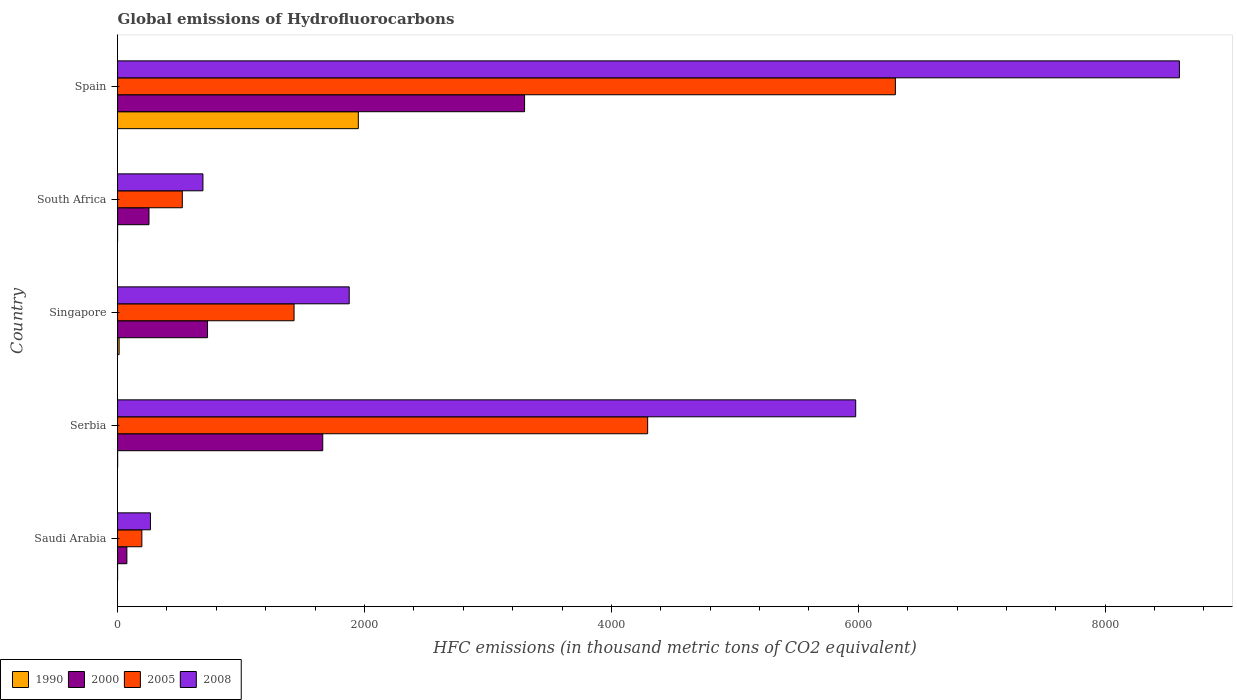Are the number of bars per tick equal to the number of legend labels?
Your response must be concise. Yes. How many bars are there on the 2nd tick from the top?
Ensure brevity in your answer.  4. In how many cases, is the number of bars for a given country not equal to the number of legend labels?
Make the answer very short. 0. What is the global emissions of Hydrofluorocarbons in 2008 in Serbia?
Your response must be concise. 5979. Across all countries, what is the maximum global emissions of Hydrofluorocarbons in 2008?
Make the answer very short. 8600.9. Across all countries, what is the minimum global emissions of Hydrofluorocarbons in 2008?
Your response must be concise. 266.5. In which country was the global emissions of Hydrofluorocarbons in 2005 maximum?
Offer a terse response. Spain. In which country was the global emissions of Hydrofluorocarbons in 2000 minimum?
Your answer should be very brief. Saudi Arabia. What is the total global emissions of Hydrofluorocarbons in 2000 in the graph?
Offer a very short reply. 6017.8. What is the difference between the global emissions of Hydrofluorocarbons in 2005 in Serbia and that in Singapore?
Offer a terse response. 2864.1. What is the difference between the global emissions of Hydrofluorocarbons in 2005 in Singapore and the global emissions of Hydrofluorocarbons in 2008 in Spain?
Make the answer very short. -7171.2. What is the average global emissions of Hydrofluorocarbons in 2005 per country?
Offer a terse response. 2549.04. What is the difference between the global emissions of Hydrofluorocarbons in 1990 and global emissions of Hydrofluorocarbons in 2000 in Serbia?
Your answer should be very brief. -1661.5. What is the ratio of the global emissions of Hydrofluorocarbons in 2000 in Serbia to that in South Africa?
Your response must be concise. 6.53. Is the global emissions of Hydrofluorocarbons in 2000 in Singapore less than that in Spain?
Your response must be concise. Yes. Is the difference between the global emissions of Hydrofluorocarbons in 1990 in Serbia and South Africa greater than the difference between the global emissions of Hydrofluorocarbons in 2000 in Serbia and South Africa?
Provide a succinct answer. No. What is the difference between the highest and the second highest global emissions of Hydrofluorocarbons in 2008?
Make the answer very short. 2621.9. What is the difference between the highest and the lowest global emissions of Hydrofluorocarbons in 2005?
Give a very brief answer. 6103.4. Is the sum of the global emissions of Hydrofluorocarbons in 2005 in Saudi Arabia and Singapore greater than the maximum global emissions of Hydrofluorocarbons in 2000 across all countries?
Your response must be concise. No. Is it the case that in every country, the sum of the global emissions of Hydrofluorocarbons in 2000 and global emissions of Hydrofluorocarbons in 1990 is greater than the sum of global emissions of Hydrofluorocarbons in 2008 and global emissions of Hydrofluorocarbons in 2005?
Provide a succinct answer. No. What does the 3rd bar from the top in Spain represents?
Your answer should be very brief. 2000. What does the 2nd bar from the bottom in South Africa represents?
Provide a short and direct response. 2000. How many bars are there?
Make the answer very short. 20. Are all the bars in the graph horizontal?
Offer a very short reply. Yes. What is the difference between two consecutive major ticks on the X-axis?
Offer a very short reply. 2000. Does the graph contain any zero values?
Your response must be concise. No. How many legend labels are there?
Ensure brevity in your answer.  4. How are the legend labels stacked?
Give a very brief answer. Horizontal. What is the title of the graph?
Your answer should be very brief. Global emissions of Hydrofluorocarbons. What is the label or title of the X-axis?
Provide a succinct answer. HFC emissions (in thousand metric tons of CO2 equivalent). What is the HFC emissions (in thousand metric tons of CO2 equivalent) in 1990 in Saudi Arabia?
Your response must be concise. 0.1. What is the HFC emissions (in thousand metric tons of CO2 equivalent) in 2000 in Saudi Arabia?
Your answer should be compact. 75.5. What is the HFC emissions (in thousand metric tons of CO2 equivalent) in 2005 in Saudi Arabia?
Keep it short and to the point. 196.9. What is the HFC emissions (in thousand metric tons of CO2 equivalent) of 2008 in Saudi Arabia?
Keep it short and to the point. 266.5. What is the HFC emissions (in thousand metric tons of CO2 equivalent) of 2000 in Serbia?
Ensure brevity in your answer.  1662. What is the HFC emissions (in thousand metric tons of CO2 equivalent) in 2005 in Serbia?
Give a very brief answer. 4293.8. What is the HFC emissions (in thousand metric tons of CO2 equivalent) in 2008 in Serbia?
Provide a short and direct response. 5979. What is the HFC emissions (in thousand metric tons of CO2 equivalent) in 1990 in Singapore?
Your response must be concise. 12.6. What is the HFC emissions (in thousand metric tons of CO2 equivalent) in 2000 in Singapore?
Keep it short and to the point. 728.9. What is the HFC emissions (in thousand metric tons of CO2 equivalent) of 2005 in Singapore?
Your answer should be compact. 1429.7. What is the HFC emissions (in thousand metric tons of CO2 equivalent) in 2008 in Singapore?
Ensure brevity in your answer.  1876.4. What is the HFC emissions (in thousand metric tons of CO2 equivalent) of 1990 in South Africa?
Offer a very short reply. 0.2. What is the HFC emissions (in thousand metric tons of CO2 equivalent) of 2000 in South Africa?
Keep it short and to the point. 254.6. What is the HFC emissions (in thousand metric tons of CO2 equivalent) in 2005 in South Africa?
Offer a very short reply. 524.5. What is the HFC emissions (in thousand metric tons of CO2 equivalent) in 2008 in South Africa?
Give a very brief answer. 691.6. What is the HFC emissions (in thousand metric tons of CO2 equivalent) of 1990 in Spain?
Provide a short and direct response. 1950.3. What is the HFC emissions (in thousand metric tons of CO2 equivalent) of 2000 in Spain?
Ensure brevity in your answer.  3296.8. What is the HFC emissions (in thousand metric tons of CO2 equivalent) of 2005 in Spain?
Your answer should be compact. 6300.3. What is the HFC emissions (in thousand metric tons of CO2 equivalent) of 2008 in Spain?
Make the answer very short. 8600.9. Across all countries, what is the maximum HFC emissions (in thousand metric tons of CO2 equivalent) of 1990?
Keep it short and to the point. 1950.3. Across all countries, what is the maximum HFC emissions (in thousand metric tons of CO2 equivalent) in 2000?
Your answer should be very brief. 3296.8. Across all countries, what is the maximum HFC emissions (in thousand metric tons of CO2 equivalent) in 2005?
Give a very brief answer. 6300.3. Across all countries, what is the maximum HFC emissions (in thousand metric tons of CO2 equivalent) of 2008?
Provide a short and direct response. 8600.9. Across all countries, what is the minimum HFC emissions (in thousand metric tons of CO2 equivalent) in 1990?
Offer a very short reply. 0.1. Across all countries, what is the minimum HFC emissions (in thousand metric tons of CO2 equivalent) of 2000?
Your answer should be very brief. 75.5. Across all countries, what is the minimum HFC emissions (in thousand metric tons of CO2 equivalent) in 2005?
Offer a very short reply. 196.9. Across all countries, what is the minimum HFC emissions (in thousand metric tons of CO2 equivalent) of 2008?
Provide a succinct answer. 266.5. What is the total HFC emissions (in thousand metric tons of CO2 equivalent) of 1990 in the graph?
Offer a terse response. 1963.7. What is the total HFC emissions (in thousand metric tons of CO2 equivalent) in 2000 in the graph?
Provide a succinct answer. 6017.8. What is the total HFC emissions (in thousand metric tons of CO2 equivalent) in 2005 in the graph?
Keep it short and to the point. 1.27e+04. What is the total HFC emissions (in thousand metric tons of CO2 equivalent) of 2008 in the graph?
Your response must be concise. 1.74e+04. What is the difference between the HFC emissions (in thousand metric tons of CO2 equivalent) in 1990 in Saudi Arabia and that in Serbia?
Make the answer very short. -0.4. What is the difference between the HFC emissions (in thousand metric tons of CO2 equivalent) of 2000 in Saudi Arabia and that in Serbia?
Ensure brevity in your answer.  -1586.5. What is the difference between the HFC emissions (in thousand metric tons of CO2 equivalent) in 2005 in Saudi Arabia and that in Serbia?
Provide a succinct answer. -4096.9. What is the difference between the HFC emissions (in thousand metric tons of CO2 equivalent) of 2008 in Saudi Arabia and that in Serbia?
Offer a very short reply. -5712.5. What is the difference between the HFC emissions (in thousand metric tons of CO2 equivalent) in 2000 in Saudi Arabia and that in Singapore?
Your response must be concise. -653.4. What is the difference between the HFC emissions (in thousand metric tons of CO2 equivalent) in 2005 in Saudi Arabia and that in Singapore?
Provide a short and direct response. -1232.8. What is the difference between the HFC emissions (in thousand metric tons of CO2 equivalent) of 2008 in Saudi Arabia and that in Singapore?
Provide a succinct answer. -1609.9. What is the difference between the HFC emissions (in thousand metric tons of CO2 equivalent) in 1990 in Saudi Arabia and that in South Africa?
Your answer should be very brief. -0.1. What is the difference between the HFC emissions (in thousand metric tons of CO2 equivalent) of 2000 in Saudi Arabia and that in South Africa?
Offer a very short reply. -179.1. What is the difference between the HFC emissions (in thousand metric tons of CO2 equivalent) in 2005 in Saudi Arabia and that in South Africa?
Make the answer very short. -327.6. What is the difference between the HFC emissions (in thousand metric tons of CO2 equivalent) in 2008 in Saudi Arabia and that in South Africa?
Offer a very short reply. -425.1. What is the difference between the HFC emissions (in thousand metric tons of CO2 equivalent) in 1990 in Saudi Arabia and that in Spain?
Provide a succinct answer. -1950.2. What is the difference between the HFC emissions (in thousand metric tons of CO2 equivalent) in 2000 in Saudi Arabia and that in Spain?
Keep it short and to the point. -3221.3. What is the difference between the HFC emissions (in thousand metric tons of CO2 equivalent) of 2005 in Saudi Arabia and that in Spain?
Provide a succinct answer. -6103.4. What is the difference between the HFC emissions (in thousand metric tons of CO2 equivalent) of 2008 in Saudi Arabia and that in Spain?
Offer a terse response. -8334.4. What is the difference between the HFC emissions (in thousand metric tons of CO2 equivalent) of 2000 in Serbia and that in Singapore?
Your response must be concise. 933.1. What is the difference between the HFC emissions (in thousand metric tons of CO2 equivalent) in 2005 in Serbia and that in Singapore?
Provide a short and direct response. 2864.1. What is the difference between the HFC emissions (in thousand metric tons of CO2 equivalent) of 2008 in Serbia and that in Singapore?
Ensure brevity in your answer.  4102.6. What is the difference between the HFC emissions (in thousand metric tons of CO2 equivalent) in 1990 in Serbia and that in South Africa?
Your answer should be compact. 0.3. What is the difference between the HFC emissions (in thousand metric tons of CO2 equivalent) in 2000 in Serbia and that in South Africa?
Your response must be concise. 1407.4. What is the difference between the HFC emissions (in thousand metric tons of CO2 equivalent) of 2005 in Serbia and that in South Africa?
Provide a succinct answer. 3769.3. What is the difference between the HFC emissions (in thousand metric tons of CO2 equivalent) of 2008 in Serbia and that in South Africa?
Ensure brevity in your answer.  5287.4. What is the difference between the HFC emissions (in thousand metric tons of CO2 equivalent) of 1990 in Serbia and that in Spain?
Keep it short and to the point. -1949.8. What is the difference between the HFC emissions (in thousand metric tons of CO2 equivalent) in 2000 in Serbia and that in Spain?
Provide a short and direct response. -1634.8. What is the difference between the HFC emissions (in thousand metric tons of CO2 equivalent) of 2005 in Serbia and that in Spain?
Offer a very short reply. -2006.5. What is the difference between the HFC emissions (in thousand metric tons of CO2 equivalent) in 2008 in Serbia and that in Spain?
Offer a terse response. -2621.9. What is the difference between the HFC emissions (in thousand metric tons of CO2 equivalent) of 1990 in Singapore and that in South Africa?
Ensure brevity in your answer.  12.4. What is the difference between the HFC emissions (in thousand metric tons of CO2 equivalent) in 2000 in Singapore and that in South Africa?
Your answer should be very brief. 474.3. What is the difference between the HFC emissions (in thousand metric tons of CO2 equivalent) in 2005 in Singapore and that in South Africa?
Provide a succinct answer. 905.2. What is the difference between the HFC emissions (in thousand metric tons of CO2 equivalent) in 2008 in Singapore and that in South Africa?
Offer a terse response. 1184.8. What is the difference between the HFC emissions (in thousand metric tons of CO2 equivalent) of 1990 in Singapore and that in Spain?
Your response must be concise. -1937.7. What is the difference between the HFC emissions (in thousand metric tons of CO2 equivalent) in 2000 in Singapore and that in Spain?
Ensure brevity in your answer.  -2567.9. What is the difference between the HFC emissions (in thousand metric tons of CO2 equivalent) of 2005 in Singapore and that in Spain?
Provide a succinct answer. -4870.6. What is the difference between the HFC emissions (in thousand metric tons of CO2 equivalent) in 2008 in Singapore and that in Spain?
Keep it short and to the point. -6724.5. What is the difference between the HFC emissions (in thousand metric tons of CO2 equivalent) of 1990 in South Africa and that in Spain?
Give a very brief answer. -1950.1. What is the difference between the HFC emissions (in thousand metric tons of CO2 equivalent) of 2000 in South Africa and that in Spain?
Provide a succinct answer. -3042.2. What is the difference between the HFC emissions (in thousand metric tons of CO2 equivalent) in 2005 in South Africa and that in Spain?
Your answer should be very brief. -5775.8. What is the difference between the HFC emissions (in thousand metric tons of CO2 equivalent) in 2008 in South Africa and that in Spain?
Your response must be concise. -7909.3. What is the difference between the HFC emissions (in thousand metric tons of CO2 equivalent) in 1990 in Saudi Arabia and the HFC emissions (in thousand metric tons of CO2 equivalent) in 2000 in Serbia?
Keep it short and to the point. -1661.9. What is the difference between the HFC emissions (in thousand metric tons of CO2 equivalent) of 1990 in Saudi Arabia and the HFC emissions (in thousand metric tons of CO2 equivalent) of 2005 in Serbia?
Offer a very short reply. -4293.7. What is the difference between the HFC emissions (in thousand metric tons of CO2 equivalent) of 1990 in Saudi Arabia and the HFC emissions (in thousand metric tons of CO2 equivalent) of 2008 in Serbia?
Offer a very short reply. -5978.9. What is the difference between the HFC emissions (in thousand metric tons of CO2 equivalent) in 2000 in Saudi Arabia and the HFC emissions (in thousand metric tons of CO2 equivalent) in 2005 in Serbia?
Make the answer very short. -4218.3. What is the difference between the HFC emissions (in thousand metric tons of CO2 equivalent) of 2000 in Saudi Arabia and the HFC emissions (in thousand metric tons of CO2 equivalent) of 2008 in Serbia?
Give a very brief answer. -5903.5. What is the difference between the HFC emissions (in thousand metric tons of CO2 equivalent) of 2005 in Saudi Arabia and the HFC emissions (in thousand metric tons of CO2 equivalent) of 2008 in Serbia?
Ensure brevity in your answer.  -5782.1. What is the difference between the HFC emissions (in thousand metric tons of CO2 equivalent) of 1990 in Saudi Arabia and the HFC emissions (in thousand metric tons of CO2 equivalent) of 2000 in Singapore?
Your answer should be compact. -728.8. What is the difference between the HFC emissions (in thousand metric tons of CO2 equivalent) in 1990 in Saudi Arabia and the HFC emissions (in thousand metric tons of CO2 equivalent) in 2005 in Singapore?
Ensure brevity in your answer.  -1429.6. What is the difference between the HFC emissions (in thousand metric tons of CO2 equivalent) of 1990 in Saudi Arabia and the HFC emissions (in thousand metric tons of CO2 equivalent) of 2008 in Singapore?
Keep it short and to the point. -1876.3. What is the difference between the HFC emissions (in thousand metric tons of CO2 equivalent) of 2000 in Saudi Arabia and the HFC emissions (in thousand metric tons of CO2 equivalent) of 2005 in Singapore?
Ensure brevity in your answer.  -1354.2. What is the difference between the HFC emissions (in thousand metric tons of CO2 equivalent) in 2000 in Saudi Arabia and the HFC emissions (in thousand metric tons of CO2 equivalent) in 2008 in Singapore?
Make the answer very short. -1800.9. What is the difference between the HFC emissions (in thousand metric tons of CO2 equivalent) of 2005 in Saudi Arabia and the HFC emissions (in thousand metric tons of CO2 equivalent) of 2008 in Singapore?
Your answer should be compact. -1679.5. What is the difference between the HFC emissions (in thousand metric tons of CO2 equivalent) of 1990 in Saudi Arabia and the HFC emissions (in thousand metric tons of CO2 equivalent) of 2000 in South Africa?
Ensure brevity in your answer.  -254.5. What is the difference between the HFC emissions (in thousand metric tons of CO2 equivalent) of 1990 in Saudi Arabia and the HFC emissions (in thousand metric tons of CO2 equivalent) of 2005 in South Africa?
Offer a terse response. -524.4. What is the difference between the HFC emissions (in thousand metric tons of CO2 equivalent) of 1990 in Saudi Arabia and the HFC emissions (in thousand metric tons of CO2 equivalent) of 2008 in South Africa?
Keep it short and to the point. -691.5. What is the difference between the HFC emissions (in thousand metric tons of CO2 equivalent) in 2000 in Saudi Arabia and the HFC emissions (in thousand metric tons of CO2 equivalent) in 2005 in South Africa?
Keep it short and to the point. -449. What is the difference between the HFC emissions (in thousand metric tons of CO2 equivalent) of 2000 in Saudi Arabia and the HFC emissions (in thousand metric tons of CO2 equivalent) of 2008 in South Africa?
Your answer should be very brief. -616.1. What is the difference between the HFC emissions (in thousand metric tons of CO2 equivalent) in 2005 in Saudi Arabia and the HFC emissions (in thousand metric tons of CO2 equivalent) in 2008 in South Africa?
Your response must be concise. -494.7. What is the difference between the HFC emissions (in thousand metric tons of CO2 equivalent) of 1990 in Saudi Arabia and the HFC emissions (in thousand metric tons of CO2 equivalent) of 2000 in Spain?
Your answer should be very brief. -3296.7. What is the difference between the HFC emissions (in thousand metric tons of CO2 equivalent) of 1990 in Saudi Arabia and the HFC emissions (in thousand metric tons of CO2 equivalent) of 2005 in Spain?
Your response must be concise. -6300.2. What is the difference between the HFC emissions (in thousand metric tons of CO2 equivalent) in 1990 in Saudi Arabia and the HFC emissions (in thousand metric tons of CO2 equivalent) in 2008 in Spain?
Your response must be concise. -8600.8. What is the difference between the HFC emissions (in thousand metric tons of CO2 equivalent) in 2000 in Saudi Arabia and the HFC emissions (in thousand metric tons of CO2 equivalent) in 2005 in Spain?
Provide a short and direct response. -6224.8. What is the difference between the HFC emissions (in thousand metric tons of CO2 equivalent) of 2000 in Saudi Arabia and the HFC emissions (in thousand metric tons of CO2 equivalent) of 2008 in Spain?
Give a very brief answer. -8525.4. What is the difference between the HFC emissions (in thousand metric tons of CO2 equivalent) of 2005 in Saudi Arabia and the HFC emissions (in thousand metric tons of CO2 equivalent) of 2008 in Spain?
Your response must be concise. -8404. What is the difference between the HFC emissions (in thousand metric tons of CO2 equivalent) of 1990 in Serbia and the HFC emissions (in thousand metric tons of CO2 equivalent) of 2000 in Singapore?
Give a very brief answer. -728.4. What is the difference between the HFC emissions (in thousand metric tons of CO2 equivalent) of 1990 in Serbia and the HFC emissions (in thousand metric tons of CO2 equivalent) of 2005 in Singapore?
Your answer should be very brief. -1429.2. What is the difference between the HFC emissions (in thousand metric tons of CO2 equivalent) in 1990 in Serbia and the HFC emissions (in thousand metric tons of CO2 equivalent) in 2008 in Singapore?
Offer a very short reply. -1875.9. What is the difference between the HFC emissions (in thousand metric tons of CO2 equivalent) in 2000 in Serbia and the HFC emissions (in thousand metric tons of CO2 equivalent) in 2005 in Singapore?
Keep it short and to the point. 232.3. What is the difference between the HFC emissions (in thousand metric tons of CO2 equivalent) in 2000 in Serbia and the HFC emissions (in thousand metric tons of CO2 equivalent) in 2008 in Singapore?
Ensure brevity in your answer.  -214.4. What is the difference between the HFC emissions (in thousand metric tons of CO2 equivalent) in 2005 in Serbia and the HFC emissions (in thousand metric tons of CO2 equivalent) in 2008 in Singapore?
Your answer should be very brief. 2417.4. What is the difference between the HFC emissions (in thousand metric tons of CO2 equivalent) in 1990 in Serbia and the HFC emissions (in thousand metric tons of CO2 equivalent) in 2000 in South Africa?
Give a very brief answer. -254.1. What is the difference between the HFC emissions (in thousand metric tons of CO2 equivalent) of 1990 in Serbia and the HFC emissions (in thousand metric tons of CO2 equivalent) of 2005 in South Africa?
Keep it short and to the point. -524. What is the difference between the HFC emissions (in thousand metric tons of CO2 equivalent) in 1990 in Serbia and the HFC emissions (in thousand metric tons of CO2 equivalent) in 2008 in South Africa?
Offer a terse response. -691.1. What is the difference between the HFC emissions (in thousand metric tons of CO2 equivalent) in 2000 in Serbia and the HFC emissions (in thousand metric tons of CO2 equivalent) in 2005 in South Africa?
Your answer should be compact. 1137.5. What is the difference between the HFC emissions (in thousand metric tons of CO2 equivalent) of 2000 in Serbia and the HFC emissions (in thousand metric tons of CO2 equivalent) of 2008 in South Africa?
Keep it short and to the point. 970.4. What is the difference between the HFC emissions (in thousand metric tons of CO2 equivalent) in 2005 in Serbia and the HFC emissions (in thousand metric tons of CO2 equivalent) in 2008 in South Africa?
Provide a short and direct response. 3602.2. What is the difference between the HFC emissions (in thousand metric tons of CO2 equivalent) in 1990 in Serbia and the HFC emissions (in thousand metric tons of CO2 equivalent) in 2000 in Spain?
Offer a terse response. -3296.3. What is the difference between the HFC emissions (in thousand metric tons of CO2 equivalent) of 1990 in Serbia and the HFC emissions (in thousand metric tons of CO2 equivalent) of 2005 in Spain?
Your answer should be compact. -6299.8. What is the difference between the HFC emissions (in thousand metric tons of CO2 equivalent) of 1990 in Serbia and the HFC emissions (in thousand metric tons of CO2 equivalent) of 2008 in Spain?
Give a very brief answer. -8600.4. What is the difference between the HFC emissions (in thousand metric tons of CO2 equivalent) of 2000 in Serbia and the HFC emissions (in thousand metric tons of CO2 equivalent) of 2005 in Spain?
Your answer should be compact. -4638.3. What is the difference between the HFC emissions (in thousand metric tons of CO2 equivalent) in 2000 in Serbia and the HFC emissions (in thousand metric tons of CO2 equivalent) in 2008 in Spain?
Keep it short and to the point. -6938.9. What is the difference between the HFC emissions (in thousand metric tons of CO2 equivalent) in 2005 in Serbia and the HFC emissions (in thousand metric tons of CO2 equivalent) in 2008 in Spain?
Give a very brief answer. -4307.1. What is the difference between the HFC emissions (in thousand metric tons of CO2 equivalent) in 1990 in Singapore and the HFC emissions (in thousand metric tons of CO2 equivalent) in 2000 in South Africa?
Your response must be concise. -242. What is the difference between the HFC emissions (in thousand metric tons of CO2 equivalent) of 1990 in Singapore and the HFC emissions (in thousand metric tons of CO2 equivalent) of 2005 in South Africa?
Keep it short and to the point. -511.9. What is the difference between the HFC emissions (in thousand metric tons of CO2 equivalent) in 1990 in Singapore and the HFC emissions (in thousand metric tons of CO2 equivalent) in 2008 in South Africa?
Your answer should be compact. -679. What is the difference between the HFC emissions (in thousand metric tons of CO2 equivalent) in 2000 in Singapore and the HFC emissions (in thousand metric tons of CO2 equivalent) in 2005 in South Africa?
Offer a very short reply. 204.4. What is the difference between the HFC emissions (in thousand metric tons of CO2 equivalent) in 2000 in Singapore and the HFC emissions (in thousand metric tons of CO2 equivalent) in 2008 in South Africa?
Keep it short and to the point. 37.3. What is the difference between the HFC emissions (in thousand metric tons of CO2 equivalent) in 2005 in Singapore and the HFC emissions (in thousand metric tons of CO2 equivalent) in 2008 in South Africa?
Offer a very short reply. 738.1. What is the difference between the HFC emissions (in thousand metric tons of CO2 equivalent) of 1990 in Singapore and the HFC emissions (in thousand metric tons of CO2 equivalent) of 2000 in Spain?
Your answer should be very brief. -3284.2. What is the difference between the HFC emissions (in thousand metric tons of CO2 equivalent) of 1990 in Singapore and the HFC emissions (in thousand metric tons of CO2 equivalent) of 2005 in Spain?
Your response must be concise. -6287.7. What is the difference between the HFC emissions (in thousand metric tons of CO2 equivalent) in 1990 in Singapore and the HFC emissions (in thousand metric tons of CO2 equivalent) in 2008 in Spain?
Make the answer very short. -8588.3. What is the difference between the HFC emissions (in thousand metric tons of CO2 equivalent) in 2000 in Singapore and the HFC emissions (in thousand metric tons of CO2 equivalent) in 2005 in Spain?
Offer a very short reply. -5571.4. What is the difference between the HFC emissions (in thousand metric tons of CO2 equivalent) of 2000 in Singapore and the HFC emissions (in thousand metric tons of CO2 equivalent) of 2008 in Spain?
Offer a very short reply. -7872. What is the difference between the HFC emissions (in thousand metric tons of CO2 equivalent) of 2005 in Singapore and the HFC emissions (in thousand metric tons of CO2 equivalent) of 2008 in Spain?
Keep it short and to the point. -7171.2. What is the difference between the HFC emissions (in thousand metric tons of CO2 equivalent) in 1990 in South Africa and the HFC emissions (in thousand metric tons of CO2 equivalent) in 2000 in Spain?
Your answer should be compact. -3296.6. What is the difference between the HFC emissions (in thousand metric tons of CO2 equivalent) in 1990 in South Africa and the HFC emissions (in thousand metric tons of CO2 equivalent) in 2005 in Spain?
Make the answer very short. -6300.1. What is the difference between the HFC emissions (in thousand metric tons of CO2 equivalent) of 1990 in South Africa and the HFC emissions (in thousand metric tons of CO2 equivalent) of 2008 in Spain?
Keep it short and to the point. -8600.7. What is the difference between the HFC emissions (in thousand metric tons of CO2 equivalent) in 2000 in South Africa and the HFC emissions (in thousand metric tons of CO2 equivalent) in 2005 in Spain?
Give a very brief answer. -6045.7. What is the difference between the HFC emissions (in thousand metric tons of CO2 equivalent) in 2000 in South Africa and the HFC emissions (in thousand metric tons of CO2 equivalent) in 2008 in Spain?
Provide a succinct answer. -8346.3. What is the difference between the HFC emissions (in thousand metric tons of CO2 equivalent) in 2005 in South Africa and the HFC emissions (in thousand metric tons of CO2 equivalent) in 2008 in Spain?
Keep it short and to the point. -8076.4. What is the average HFC emissions (in thousand metric tons of CO2 equivalent) in 1990 per country?
Provide a short and direct response. 392.74. What is the average HFC emissions (in thousand metric tons of CO2 equivalent) in 2000 per country?
Give a very brief answer. 1203.56. What is the average HFC emissions (in thousand metric tons of CO2 equivalent) in 2005 per country?
Your answer should be compact. 2549.04. What is the average HFC emissions (in thousand metric tons of CO2 equivalent) of 2008 per country?
Your response must be concise. 3482.88. What is the difference between the HFC emissions (in thousand metric tons of CO2 equivalent) of 1990 and HFC emissions (in thousand metric tons of CO2 equivalent) of 2000 in Saudi Arabia?
Provide a short and direct response. -75.4. What is the difference between the HFC emissions (in thousand metric tons of CO2 equivalent) of 1990 and HFC emissions (in thousand metric tons of CO2 equivalent) of 2005 in Saudi Arabia?
Ensure brevity in your answer.  -196.8. What is the difference between the HFC emissions (in thousand metric tons of CO2 equivalent) of 1990 and HFC emissions (in thousand metric tons of CO2 equivalent) of 2008 in Saudi Arabia?
Your response must be concise. -266.4. What is the difference between the HFC emissions (in thousand metric tons of CO2 equivalent) of 2000 and HFC emissions (in thousand metric tons of CO2 equivalent) of 2005 in Saudi Arabia?
Offer a very short reply. -121.4. What is the difference between the HFC emissions (in thousand metric tons of CO2 equivalent) of 2000 and HFC emissions (in thousand metric tons of CO2 equivalent) of 2008 in Saudi Arabia?
Offer a very short reply. -191. What is the difference between the HFC emissions (in thousand metric tons of CO2 equivalent) in 2005 and HFC emissions (in thousand metric tons of CO2 equivalent) in 2008 in Saudi Arabia?
Offer a very short reply. -69.6. What is the difference between the HFC emissions (in thousand metric tons of CO2 equivalent) in 1990 and HFC emissions (in thousand metric tons of CO2 equivalent) in 2000 in Serbia?
Keep it short and to the point. -1661.5. What is the difference between the HFC emissions (in thousand metric tons of CO2 equivalent) in 1990 and HFC emissions (in thousand metric tons of CO2 equivalent) in 2005 in Serbia?
Provide a succinct answer. -4293.3. What is the difference between the HFC emissions (in thousand metric tons of CO2 equivalent) in 1990 and HFC emissions (in thousand metric tons of CO2 equivalent) in 2008 in Serbia?
Your answer should be compact. -5978.5. What is the difference between the HFC emissions (in thousand metric tons of CO2 equivalent) in 2000 and HFC emissions (in thousand metric tons of CO2 equivalent) in 2005 in Serbia?
Provide a short and direct response. -2631.8. What is the difference between the HFC emissions (in thousand metric tons of CO2 equivalent) of 2000 and HFC emissions (in thousand metric tons of CO2 equivalent) of 2008 in Serbia?
Keep it short and to the point. -4317. What is the difference between the HFC emissions (in thousand metric tons of CO2 equivalent) of 2005 and HFC emissions (in thousand metric tons of CO2 equivalent) of 2008 in Serbia?
Provide a succinct answer. -1685.2. What is the difference between the HFC emissions (in thousand metric tons of CO2 equivalent) of 1990 and HFC emissions (in thousand metric tons of CO2 equivalent) of 2000 in Singapore?
Your response must be concise. -716.3. What is the difference between the HFC emissions (in thousand metric tons of CO2 equivalent) of 1990 and HFC emissions (in thousand metric tons of CO2 equivalent) of 2005 in Singapore?
Your response must be concise. -1417.1. What is the difference between the HFC emissions (in thousand metric tons of CO2 equivalent) in 1990 and HFC emissions (in thousand metric tons of CO2 equivalent) in 2008 in Singapore?
Your answer should be very brief. -1863.8. What is the difference between the HFC emissions (in thousand metric tons of CO2 equivalent) of 2000 and HFC emissions (in thousand metric tons of CO2 equivalent) of 2005 in Singapore?
Your answer should be very brief. -700.8. What is the difference between the HFC emissions (in thousand metric tons of CO2 equivalent) in 2000 and HFC emissions (in thousand metric tons of CO2 equivalent) in 2008 in Singapore?
Your answer should be compact. -1147.5. What is the difference between the HFC emissions (in thousand metric tons of CO2 equivalent) of 2005 and HFC emissions (in thousand metric tons of CO2 equivalent) of 2008 in Singapore?
Offer a terse response. -446.7. What is the difference between the HFC emissions (in thousand metric tons of CO2 equivalent) in 1990 and HFC emissions (in thousand metric tons of CO2 equivalent) in 2000 in South Africa?
Provide a short and direct response. -254.4. What is the difference between the HFC emissions (in thousand metric tons of CO2 equivalent) of 1990 and HFC emissions (in thousand metric tons of CO2 equivalent) of 2005 in South Africa?
Provide a succinct answer. -524.3. What is the difference between the HFC emissions (in thousand metric tons of CO2 equivalent) of 1990 and HFC emissions (in thousand metric tons of CO2 equivalent) of 2008 in South Africa?
Your answer should be compact. -691.4. What is the difference between the HFC emissions (in thousand metric tons of CO2 equivalent) in 2000 and HFC emissions (in thousand metric tons of CO2 equivalent) in 2005 in South Africa?
Your response must be concise. -269.9. What is the difference between the HFC emissions (in thousand metric tons of CO2 equivalent) of 2000 and HFC emissions (in thousand metric tons of CO2 equivalent) of 2008 in South Africa?
Make the answer very short. -437. What is the difference between the HFC emissions (in thousand metric tons of CO2 equivalent) in 2005 and HFC emissions (in thousand metric tons of CO2 equivalent) in 2008 in South Africa?
Give a very brief answer. -167.1. What is the difference between the HFC emissions (in thousand metric tons of CO2 equivalent) in 1990 and HFC emissions (in thousand metric tons of CO2 equivalent) in 2000 in Spain?
Your response must be concise. -1346.5. What is the difference between the HFC emissions (in thousand metric tons of CO2 equivalent) of 1990 and HFC emissions (in thousand metric tons of CO2 equivalent) of 2005 in Spain?
Offer a terse response. -4350. What is the difference between the HFC emissions (in thousand metric tons of CO2 equivalent) of 1990 and HFC emissions (in thousand metric tons of CO2 equivalent) of 2008 in Spain?
Your answer should be very brief. -6650.6. What is the difference between the HFC emissions (in thousand metric tons of CO2 equivalent) of 2000 and HFC emissions (in thousand metric tons of CO2 equivalent) of 2005 in Spain?
Ensure brevity in your answer.  -3003.5. What is the difference between the HFC emissions (in thousand metric tons of CO2 equivalent) in 2000 and HFC emissions (in thousand metric tons of CO2 equivalent) in 2008 in Spain?
Make the answer very short. -5304.1. What is the difference between the HFC emissions (in thousand metric tons of CO2 equivalent) of 2005 and HFC emissions (in thousand metric tons of CO2 equivalent) of 2008 in Spain?
Give a very brief answer. -2300.6. What is the ratio of the HFC emissions (in thousand metric tons of CO2 equivalent) of 2000 in Saudi Arabia to that in Serbia?
Your answer should be very brief. 0.05. What is the ratio of the HFC emissions (in thousand metric tons of CO2 equivalent) in 2005 in Saudi Arabia to that in Serbia?
Ensure brevity in your answer.  0.05. What is the ratio of the HFC emissions (in thousand metric tons of CO2 equivalent) in 2008 in Saudi Arabia to that in Serbia?
Give a very brief answer. 0.04. What is the ratio of the HFC emissions (in thousand metric tons of CO2 equivalent) in 1990 in Saudi Arabia to that in Singapore?
Give a very brief answer. 0.01. What is the ratio of the HFC emissions (in thousand metric tons of CO2 equivalent) in 2000 in Saudi Arabia to that in Singapore?
Give a very brief answer. 0.1. What is the ratio of the HFC emissions (in thousand metric tons of CO2 equivalent) of 2005 in Saudi Arabia to that in Singapore?
Offer a very short reply. 0.14. What is the ratio of the HFC emissions (in thousand metric tons of CO2 equivalent) in 2008 in Saudi Arabia to that in Singapore?
Give a very brief answer. 0.14. What is the ratio of the HFC emissions (in thousand metric tons of CO2 equivalent) of 2000 in Saudi Arabia to that in South Africa?
Give a very brief answer. 0.3. What is the ratio of the HFC emissions (in thousand metric tons of CO2 equivalent) of 2005 in Saudi Arabia to that in South Africa?
Offer a terse response. 0.38. What is the ratio of the HFC emissions (in thousand metric tons of CO2 equivalent) of 2008 in Saudi Arabia to that in South Africa?
Provide a succinct answer. 0.39. What is the ratio of the HFC emissions (in thousand metric tons of CO2 equivalent) in 2000 in Saudi Arabia to that in Spain?
Offer a very short reply. 0.02. What is the ratio of the HFC emissions (in thousand metric tons of CO2 equivalent) of 2005 in Saudi Arabia to that in Spain?
Provide a succinct answer. 0.03. What is the ratio of the HFC emissions (in thousand metric tons of CO2 equivalent) of 2008 in Saudi Arabia to that in Spain?
Offer a terse response. 0.03. What is the ratio of the HFC emissions (in thousand metric tons of CO2 equivalent) in 1990 in Serbia to that in Singapore?
Provide a succinct answer. 0.04. What is the ratio of the HFC emissions (in thousand metric tons of CO2 equivalent) in 2000 in Serbia to that in Singapore?
Provide a short and direct response. 2.28. What is the ratio of the HFC emissions (in thousand metric tons of CO2 equivalent) in 2005 in Serbia to that in Singapore?
Your answer should be very brief. 3. What is the ratio of the HFC emissions (in thousand metric tons of CO2 equivalent) of 2008 in Serbia to that in Singapore?
Give a very brief answer. 3.19. What is the ratio of the HFC emissions (in thousand metric tons of CO2 equivalent) of 2000 in Serbia to that in South Africa?
Offer a very short reply. 6.53. What is the ratio of the HFC emissions (in thousand metric tons of CO2 equivalent) in 2005 in Serbia to that in South Africa?
Keep it short and to the point. 8.19. What is the ratio of the HFC emissions (in thousand metric tons of CO2 equivalent) in 2008 in Serbia to that in South Africa?
Provide a short and direct response. 8.65. What is the ratio of the HFC emissions (in thousand metric tons of CO2 equivalent) in 1990 in Serbia to that in Spain?
Your answer should be compact. 0. What is the ratio of the HFC emissions (in thousand metric tons of CO2 equivalent) of 2000 in Serbia to that in Spain?
Give a very brief answer. 0.5. What is the ratio of the HFC emissions (in thousand metric tons of CO2 equivalent) of 2005 in Serbia to that in Spain?
Make the answer very short. 0.68. What is the ratio of the HFC emissions (in thousand metric tons of CO2 equivalent) in 2008 in Serbia to that in Spain?
Provide a short and direct response. 0.7. What is the ratio of the HFC emissions (in thousand metric tons of CO2 equivalent) of 2000 in Singapore to that in South Africa?
Your answer should be compact. 2.86. What is the ratio of the HFC emissions (in thousand metric tons of CO2 equivalent) of 2005 in Singapore to that in South Africa?
Keep it short and to the point. 2.73. What is the ratio of the HFC emissions (in thousand metric tons of CO2 equivalent) in 2008 in Singapore to that in South Africa?
Ensure brevity in your answer.  2.71. What is the ratio of the HFC emissions (in thousand metric tons of CO2 equivalent) of 1990 in Singapore to that in Spain?
Provide a succinct answer. 0.01. What is the ratio of the HFC emissions (in thousand metric tons of CO2 equivalent) in 2000 in Singapore to that in Spain?
Provide a succinct answer. 0.22. What is the ratio of the HFC emissions (in thousand metric tons of CO2 equivalent) of 2005 in Singapore to that in Spain?
Keep it short and to the point. 0.23. What is the ratio of the HFC emissions (in thousand metric tons of CO2 equivalent) in 2008 in Singapore to that in Spain?
Ensure brevity in your answer.  0.22. What is the ratio of the HFC emissions (in thousand metric tons of CO2 equivalent) of 2000 in South Africa to that in Spain?
Keep it short and to the point. 0.08. What is the ratio of the HFC emissions (in thousand metric tons of CO2 equivalent) in 2005 in South Africa to that in Spain?
Keep it short and to the point. 0.08. What is the ratio of the HFC emissions (in thousand metric tons of CO2 equivalent) in 2008 in South Africa to that in Spain?
Give a very brief answer. 0.08. What is the difference between the highest and the second highest HFC emissions (in thousand metric tons of CO2 equivalent) of 1990?
Ensure brevity in your answer.  1937.7. What is the difference between the highest and the second highest HFC emissions (in thousand metric tons of CO2 equivalent) of 2000?
Keep it short and to the point. 1634.8. What is the difference between the highest and the second highest HFC emissions (in thousand metric tons of CO2 equivalent) in 2005?
Offer a terse response. 2006.5. What is the difference between the highest and the second highest HFC emissions (in thousand metric tons of CO2 equivalent) of 2008?
Your answer should be very brief. 2621.9. What is the difference between the highest and the lowest HFC emissions (in thousand metric tons of CO2 equivalent) of 1990?
Provide a succinct answer. 1950.2. What is the difference between the highest and the lowest HFC emissions (in thousand metric tons of CO2 equivalent) of 2000?
Provide a succinct answer. 3221.3. What is the difference between the highest and the lowest HFC emissions (in thousand metric tons of CO2 equivalent) of 2005?
Provide a succinct answer. 6103.4. What is the difference between the highest and the lowest HFC emissions (in thousand metric tons of CO2 equivalent) in 2008?
Make the answer very short. 8334.4. 